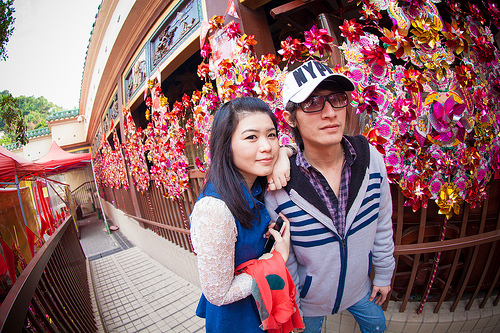<image>
Is the girl on the boy? Yes. Looking at the image, I can see the girl is positioned on top of the boy, with the boy providing support. Is there a man next to the woman? Yes. The man is positioned adjacent to the woman, located nearby in the same general area. 